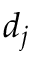<formula> <loc_0><loc_0><loc_500><loc_500>d _ { j }</formula> 